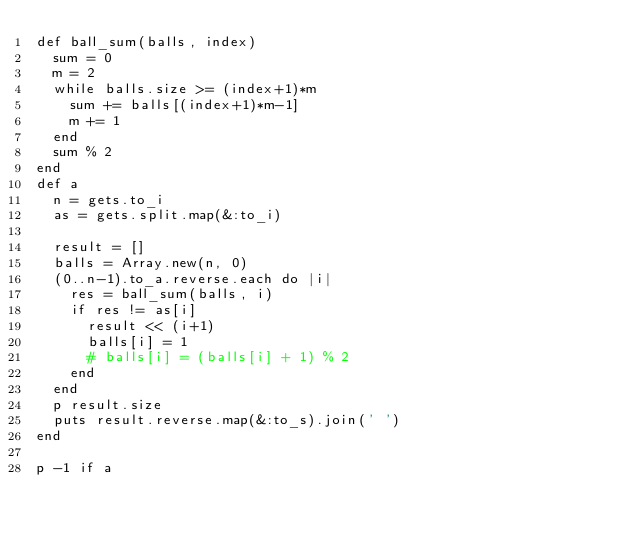Convert code to text. <code><loc_0><loc_0><loc_500><loc_500><_Ruby_>def ball_sum(balls, index)
  sum = 0
  m = 2
  while balls.size >= (index+1)*m
    sum += balls[(index+1)*m-1]
    m += 1
  end
  sum % 2
end
def a
  n = gets.to_i
  as = gets.split.map(&:to_i)

  result = []
  balls = Array.new(n, 0)
  (0..n-1).to_a.reverse.each do |i|
    res = ball_sum(balls, i)
    if res != as[i]
      result << (i+1)
      balls[i] = 1
      # balls[i] = (balls[i] + 1) % 2
    end
  end
  p result.size
  puts result.reverse.map(&:to_s).join(' ')
end

p -1 if a

</code> 